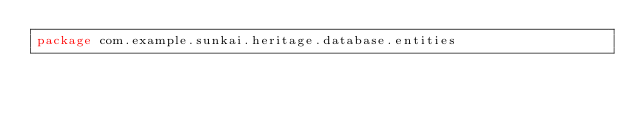Convert code to text. <code><loc_0><loc_0><loc_500><loc_500><_Kotlin_>package com.example.sunkai.heritage.database.entities
</code> 